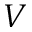<formula> <loc_0><loc_0><loc_500><loc_500>V</formula> 